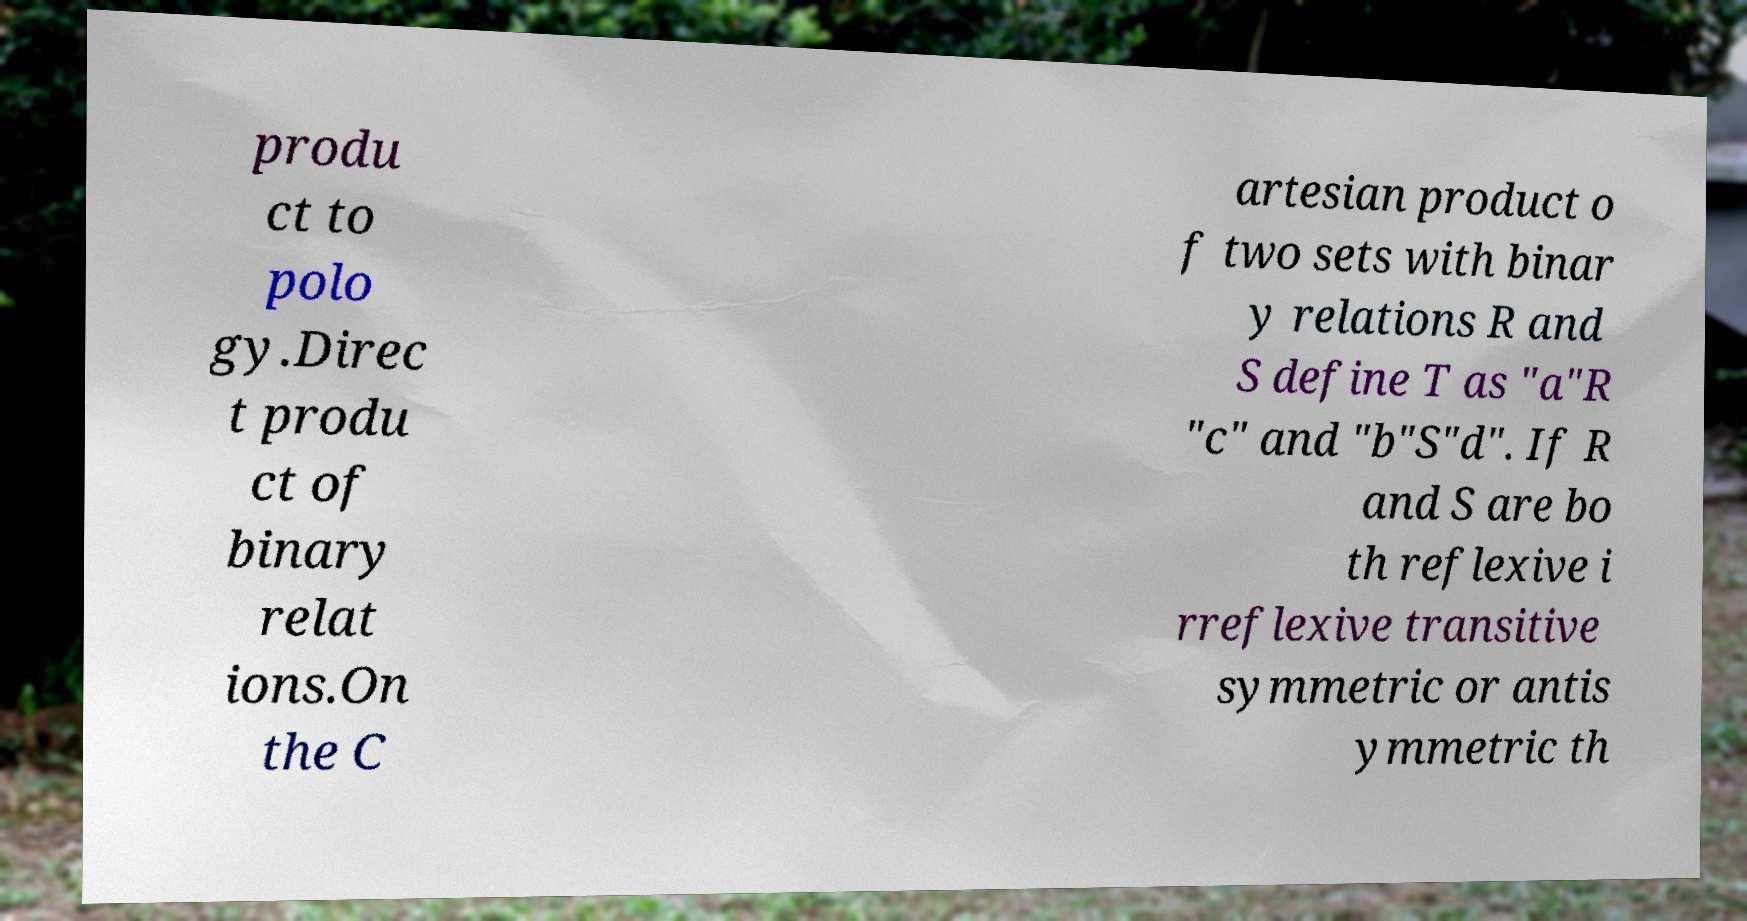Please identify and transcribe the text found in this image. produ ct to polo gy.Direc t produ ct of binary relat ions.On the C artesian product o f two sets with binar y relations R and S define T as "a"R "c" and "b"S"d". If R and S are bo th reflexive i rreflexive transitive symmetric or antis ymmetric th 